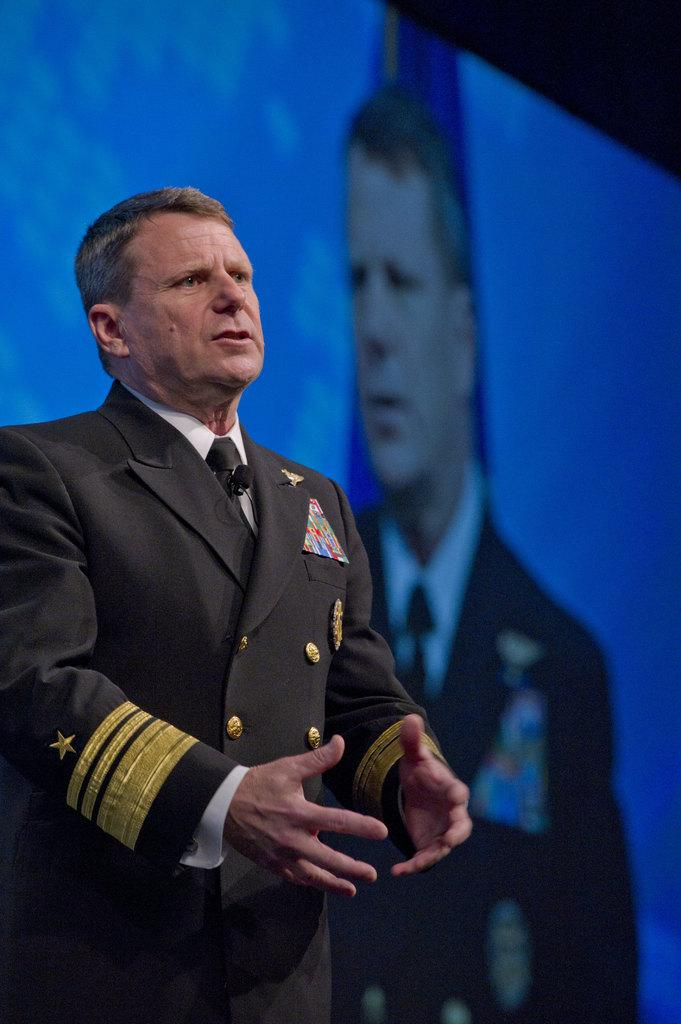Who is present in the image? There is a man in the image. What can be seen in the background of the image? There is a screen in the background of the image. What is displayed on the screen? A person is visible on the screen. What type of food is being served on the plate in the image? There is no plate or food present in the image. 